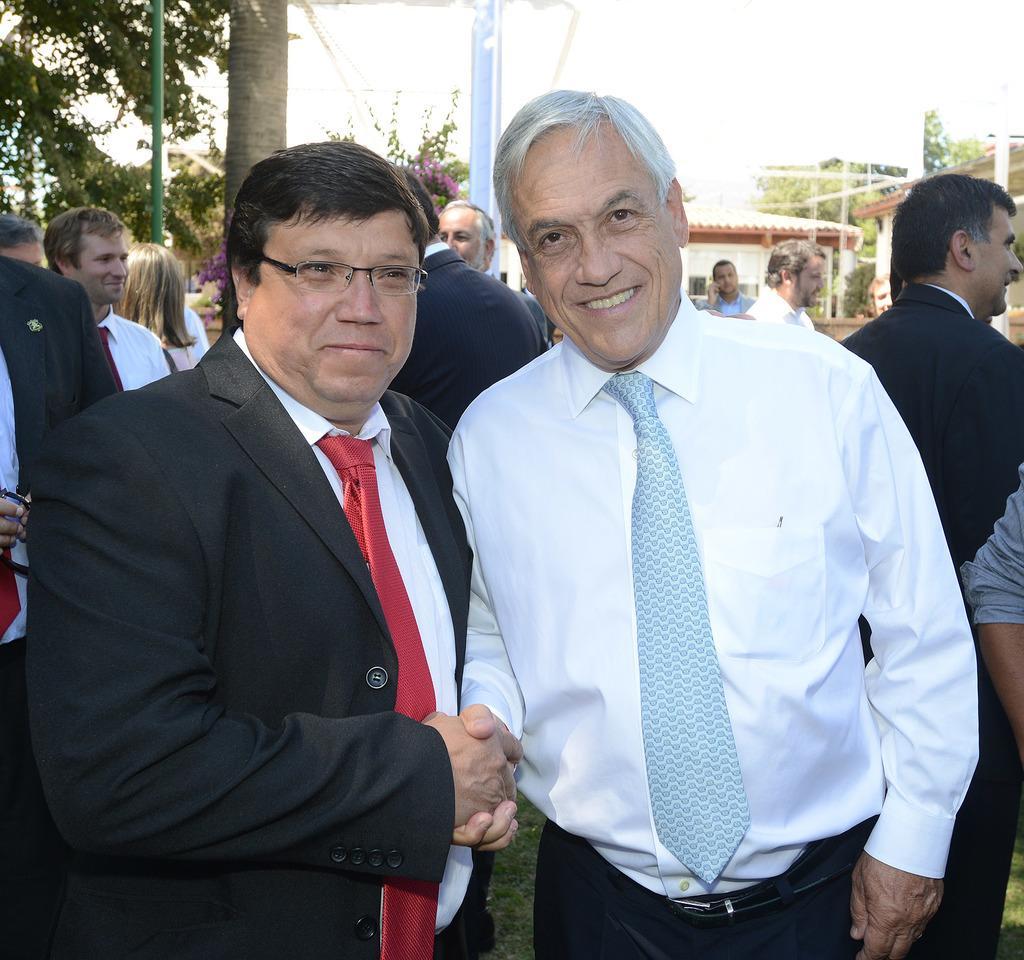Could you give a brief overview of what you see in this image? 2 people are standing and shaking hands. The person at the left is wearing a suit. There are other people at the back. There are poles, trees and buildings at the back. 